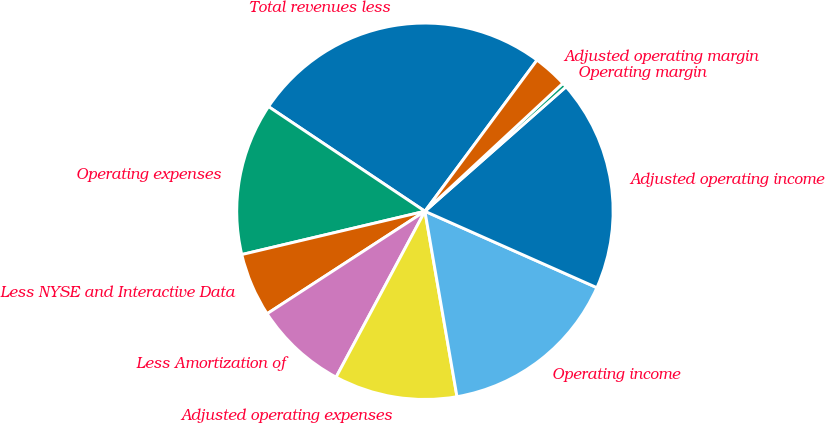Convert chart. <chart><loc_0><loc_0><loc_500><loc_500><pie_chart><fcel>Total revenues less<fcel>Operating expenses<fcel>Less NYSE and Interactive Data<fcel>Less Amortization of<fcel>Adjusted operating expenses<fcel>Operating income<fcel>Adjusted operating income<fcel>Operating margin<fcel>Adjusted operating margin<nl><fcel>25.77%<fcel>13.08%<fcel>5.47%<fcel>8.01%<fcel>10.55%<fcel>15.62%<fcel>18.16%<fcel>0.4%<fcel>2.94%<nl></chart> 